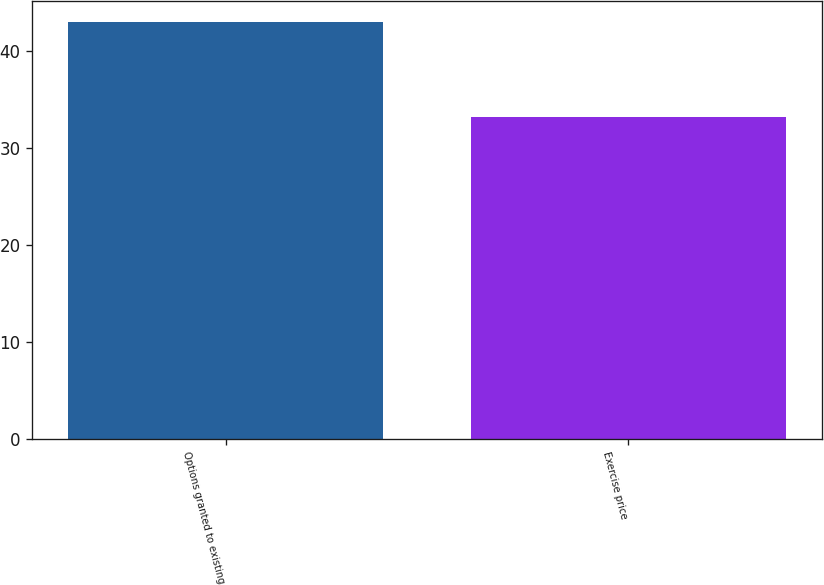<chart> <loc_0><loc_0><loc_500><loc_500><bar_chart><fcel>Options granted to existing<fcel>Exercise price<nl><fcel>43<fcel>33.18<nl></chart> 